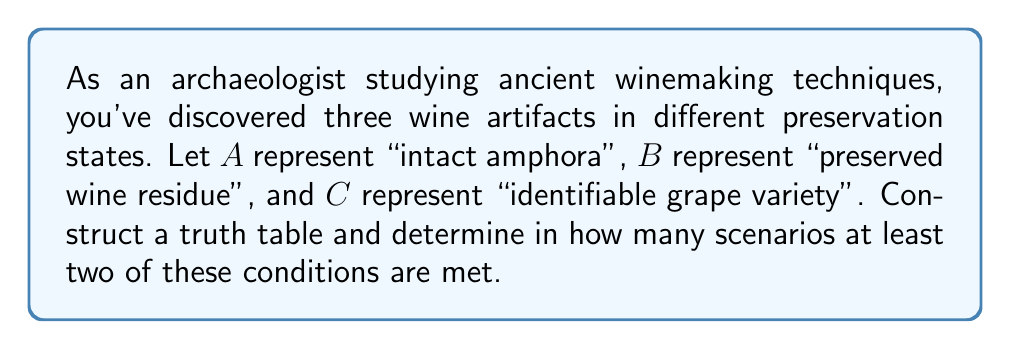Give your solution to this math problem. Let's approach this step-by-step:

1) First, we need to construct a truth table with three variables: A, B, and C.

2) The truth table will have $2^3 = 8$ rows, representing all possible combinations:

   $$
   \begin{array}{|c|c|c|c|}
   \hline
   A & B & C & \text{At least two true} \\
   \hline
   0 & 0 & 0 & 0 \\
   0 & 0 & 1 & 0 \\
   0 & 1 & 0 & 0 \\
   0 & 1 & 1 & 1 \\
   1 & 0 & 0 & 0 \\
   1 & 0 & 1 & 1 \\
   1 & 1 & 0 & 1 \\
   1 & 1 & 1 & 1 \\
   \hline
   \end{array}
   $$

3) The last column represents whether at least two conditions are true. This occurs when:
   - A and B are true (regardless of C)
   - A and C are true (regardless of B)
   - B and C are true (regardless of A)

4) We can express this logically as:

   $$(A \wedge B) \vee (A \wedge C) \vee (B \wedge C)$$

5) Counting the number of 1's in the last column of our truth table, we see that there are 4 scenarios where at least two conditions are met.
Answer: 4 scenarios 